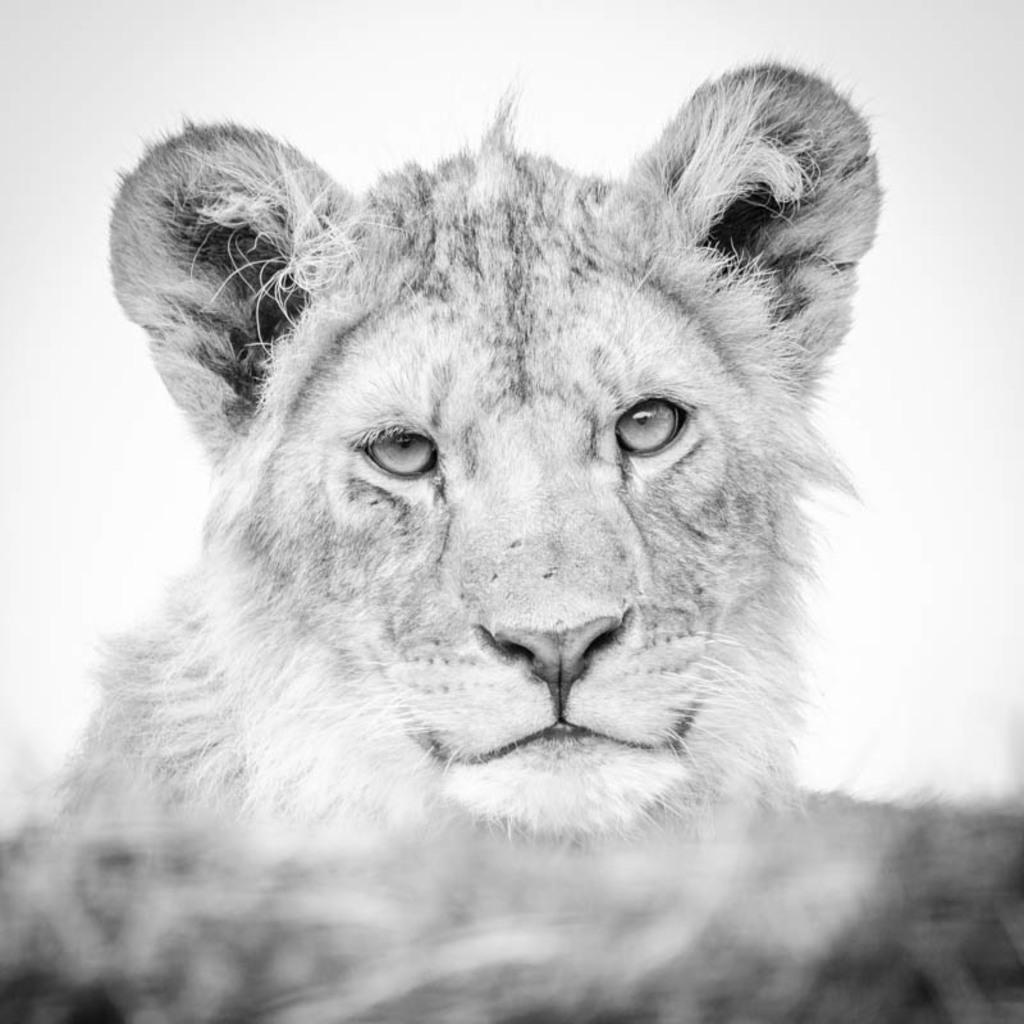What is present in the image that features a design or message? There is a poster in the image. What is the main subject or image on the poster? The poster features a tiger. Where is the poster located in the image? The poster is in the center of the image. How many dinosaurs can be seen interacting with the tiger on the poster? There are no dinosaurs present on the poster; it features a tiger. What type of material is the tin used for in the image? There is no tin present in the image. 